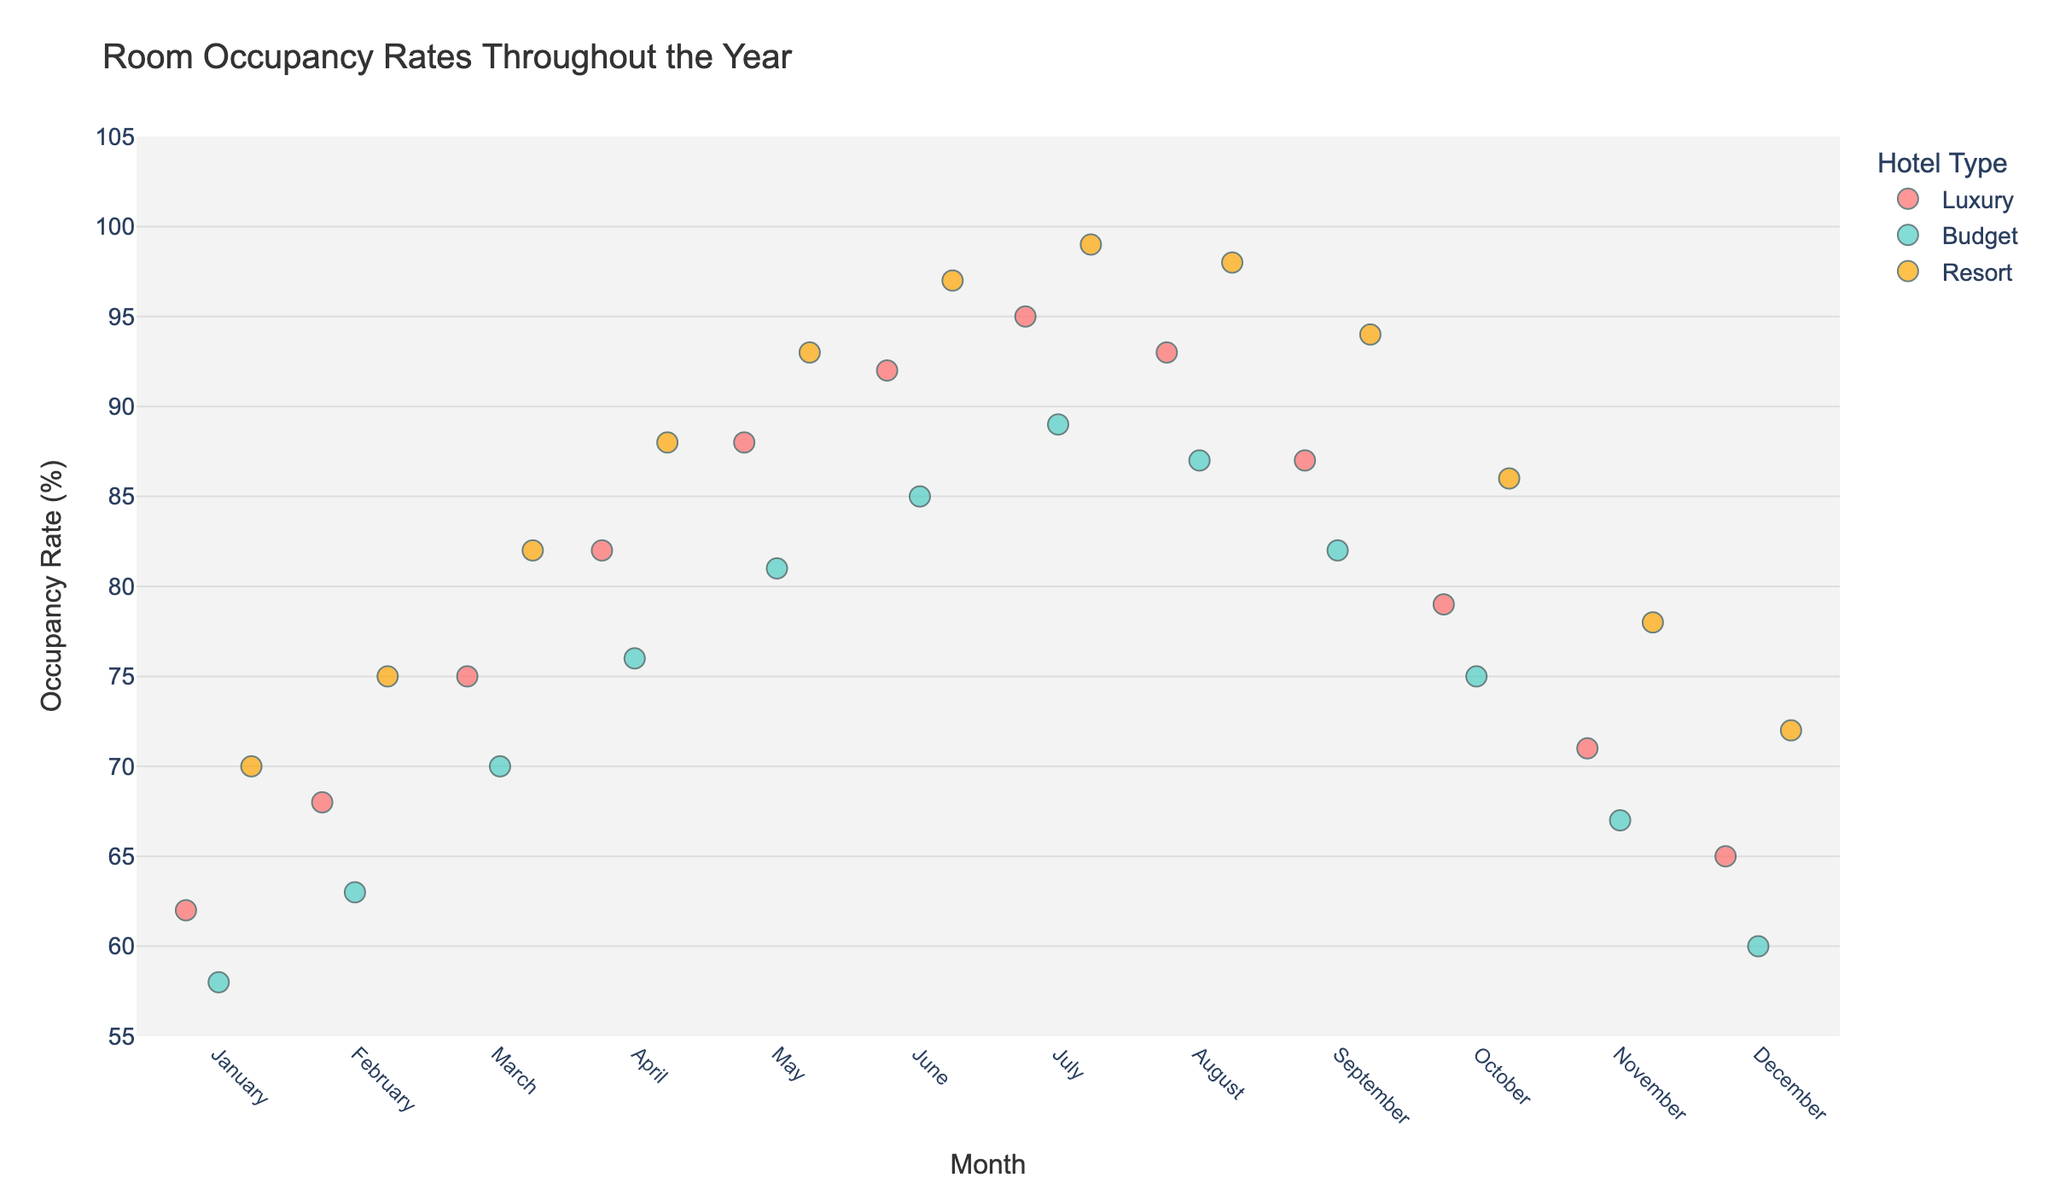What is the title of the strip plot? The title of the strip plot is displayed at the top of the figure.
Answer: Room Occupancy Rates Throughout the Year Which hotel type has the highest occupancy rate in July? By looking at the strip plot and finding the July data points, the Resort type has the highest occupancy rate.
Answer: Resort What is the average occupancy rate for Luxury hotels throughout the year? Find the occupancy rates for Luxury hotels, sum them, and divide by the number of months (12). (62 + 68 + 75 + 82 + 88 + 92 + 95 + 93 + 87 + 79 + 71 + 65) / 12 = 80.
Answer: 80 During which month do Budget hotels have the lowest occupancy rate? By checking the strip plot for the data points related to Budget hotels, January has the lowest occupancy rate.
Answer: January Compare the occupancy rate of Resort hotels between January and December. Locate the occupancy rates for Resort hotels for both January and December on the strip plot. January has a rate of 70%, while December has a rate of 72%.
Answer: December is higher What is the difference in occupancy rates between Luxury and Budget hotels in June? Locate the data points for both hotel types in June, Luxury has 92% and Budget has 85%. Calculate the difference: 92 - 85 = 7.
Answer: 7 What is the median occupancy rate for Resort hotels from April to September? Identify the occupancy rates for Resort hotels from April to September (88, 93, 97, 99, 98, 94). Sort: 88, 93, 94, 97, 98, 99. The median is the average of the middle two values (94 + 97)/2 = 95.5.
Answer: 95.5 Which month has the most diverse occupancy rates across all hotel types? Look for the month with the widest spread or biggest range between the lowest and highest rates among all three hotel types. July appears to have the widest range (Luxury 95, Budget 89, Resort 99).
Answer: July How does the occupancy rate trend for Budget hotels change from January to December? Trace the occupancy rates of Budget hotels from January to December. The rate starts at 58%, increases, peaks in July at 89%, then decreases back to 60% in December.
Answer: Rises, peaks in July, then falls Which hotel type and month combination has the highest single occupancy rate in the dataset? Identify the highest data point on the strip plot, which is Resort in July with 99%.
Answer: Resort in July 